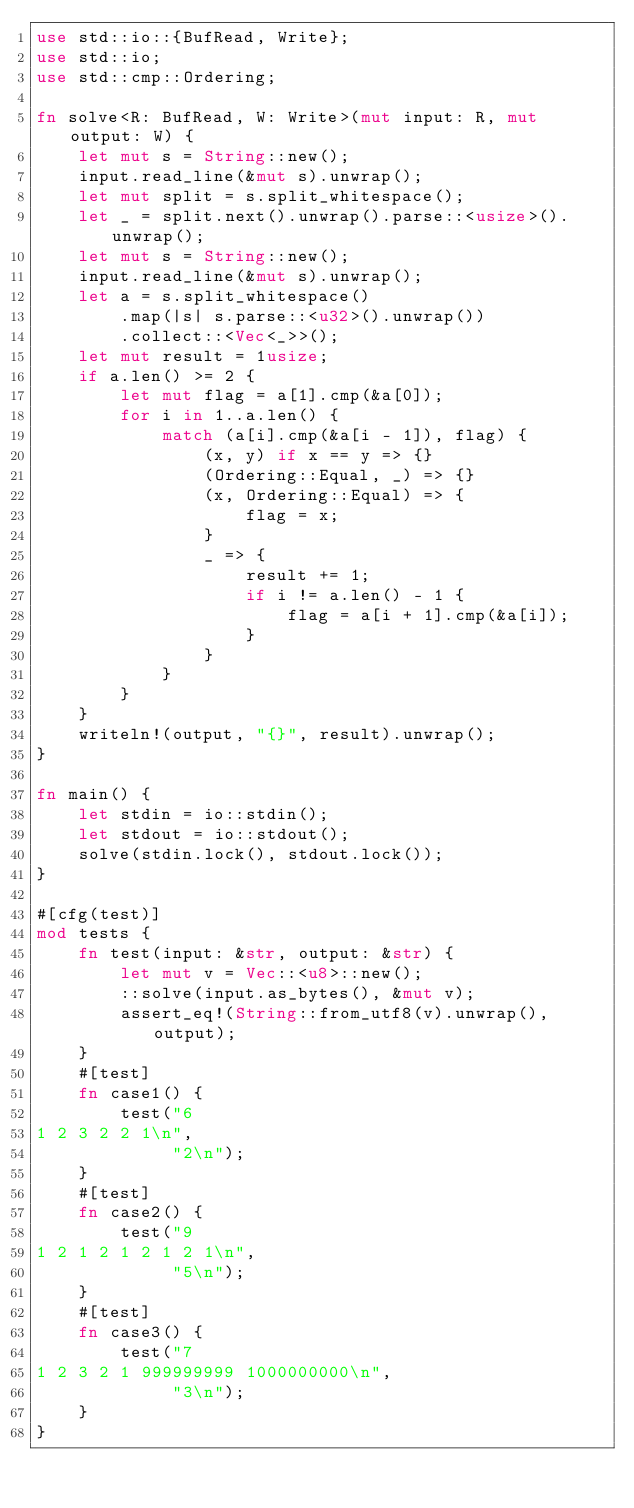Convert code to text. <code><loc_0><loc_0><loc_500><loc_500><_Rust_>use std::io::{BufRead, Write};
use std::io;
use std::cmp::Ordering;

fn solve<R: BufRead, W: Write>(mut input: R, mut output: W) {
    let mut s = String::new();
    input.read_line(&mut s).unwrap();
    let mut split = s.split_whitespace();
    let _ = split.next().unwrap().parse::<usize>().unwrap();
    let mut s = String::new();
    input.read_line(&mut s).unwrap();
    let a = s.split_whitespace()
        .map(|s| s.parse::<u32>().unwrap())
        .collect::<Vec<_>>();
    let mut result = 1usize;
    if a.len() >= 2 {
        let mut flag = a[1].cmp(&a[0]);
        for i in 1..a.len() {
            match (a[i].cmp(&a[i - 1]), flag) {
                (x, y) if x == y => {}
                (Ordering::Equal, _) => {}
                (x, Ordering::Equal) => {
                    flag = x;
                }
                _ => {
                    result += 1;
                    if i != a.len() - 1 {
                        flag = a[i + 1].cmp(&a[i]);
                    }
                }
            }
        }
    }
    writeln!(output, "{}", result).unwrap();
}

fn main() {
    let stdin = io::stdin();
    let stdout = io::stdout();
    solve(stdin.lock(), stdout.lock());
}

#[cfg(test)]
mod tests {
    fn test(input: &str, output: &str) {
        let mut v = Vec::<u8>::new();
        ::solve(input.as_bytes(), &mut v);
        assert_eq!(String::from_utf8(v).unwrap(), output);
    }
    #[test]
    fn case1() {
        test("6
1 2 3 2 2 1\n",
             "2\n");
    }
    #[test]
    fn case2() {
        test("9
1 2 1 2 1 2 1 2 1\n",
             "5\n");
    }
    #[test]
    fn case3() {
        test("7
1 2 3 2 1 999999999 1000000000\n",
             "3\n");
    }
}
</code> 